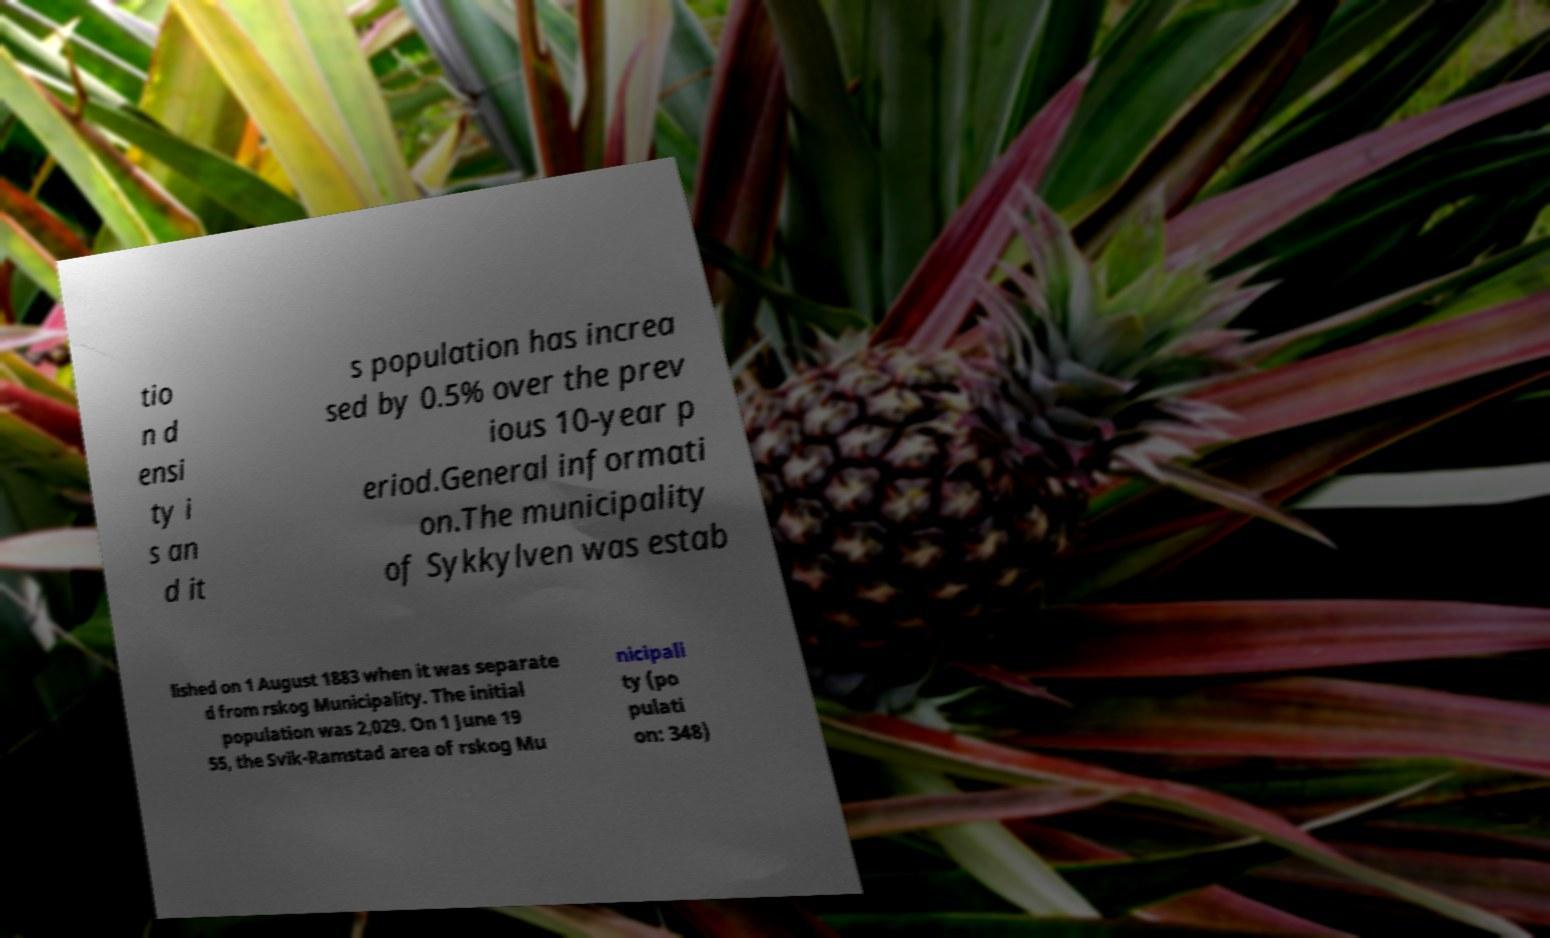Please identify and transcribe the text found in this image. tio n d ensi ty i s an d it s population has increa sed by 0.5% over the prev ious 10-year p eriod.General informati on.The municipality of Sykkylven was estab lished on 1 August 1883 when it was separate d from rskog Municipality. The initial population was 2,029. On 1 June 19 55, the Svik-Ramstad area of rskog Mu nicipali ty (po pulati on: 348) 